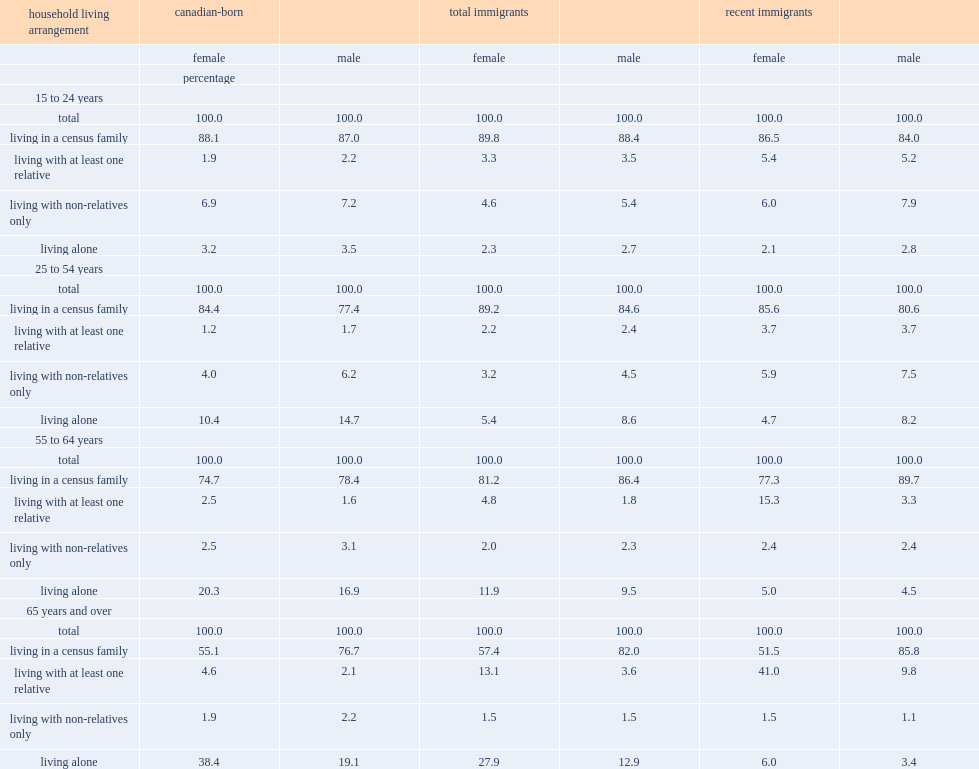What was the percentage of canadian-born women lived in a census family in 55 to 64 years group? 74.7. What was the percentage of immigrant women lived in a census family in 55 to 64 years group? 81.2. What was the percentage of canadian-born women lived in a census family in aged 65 and older years group? 55.1. What was the percentage of immigrant women lived in a census family in aged 65 and older years group? 57.4. 